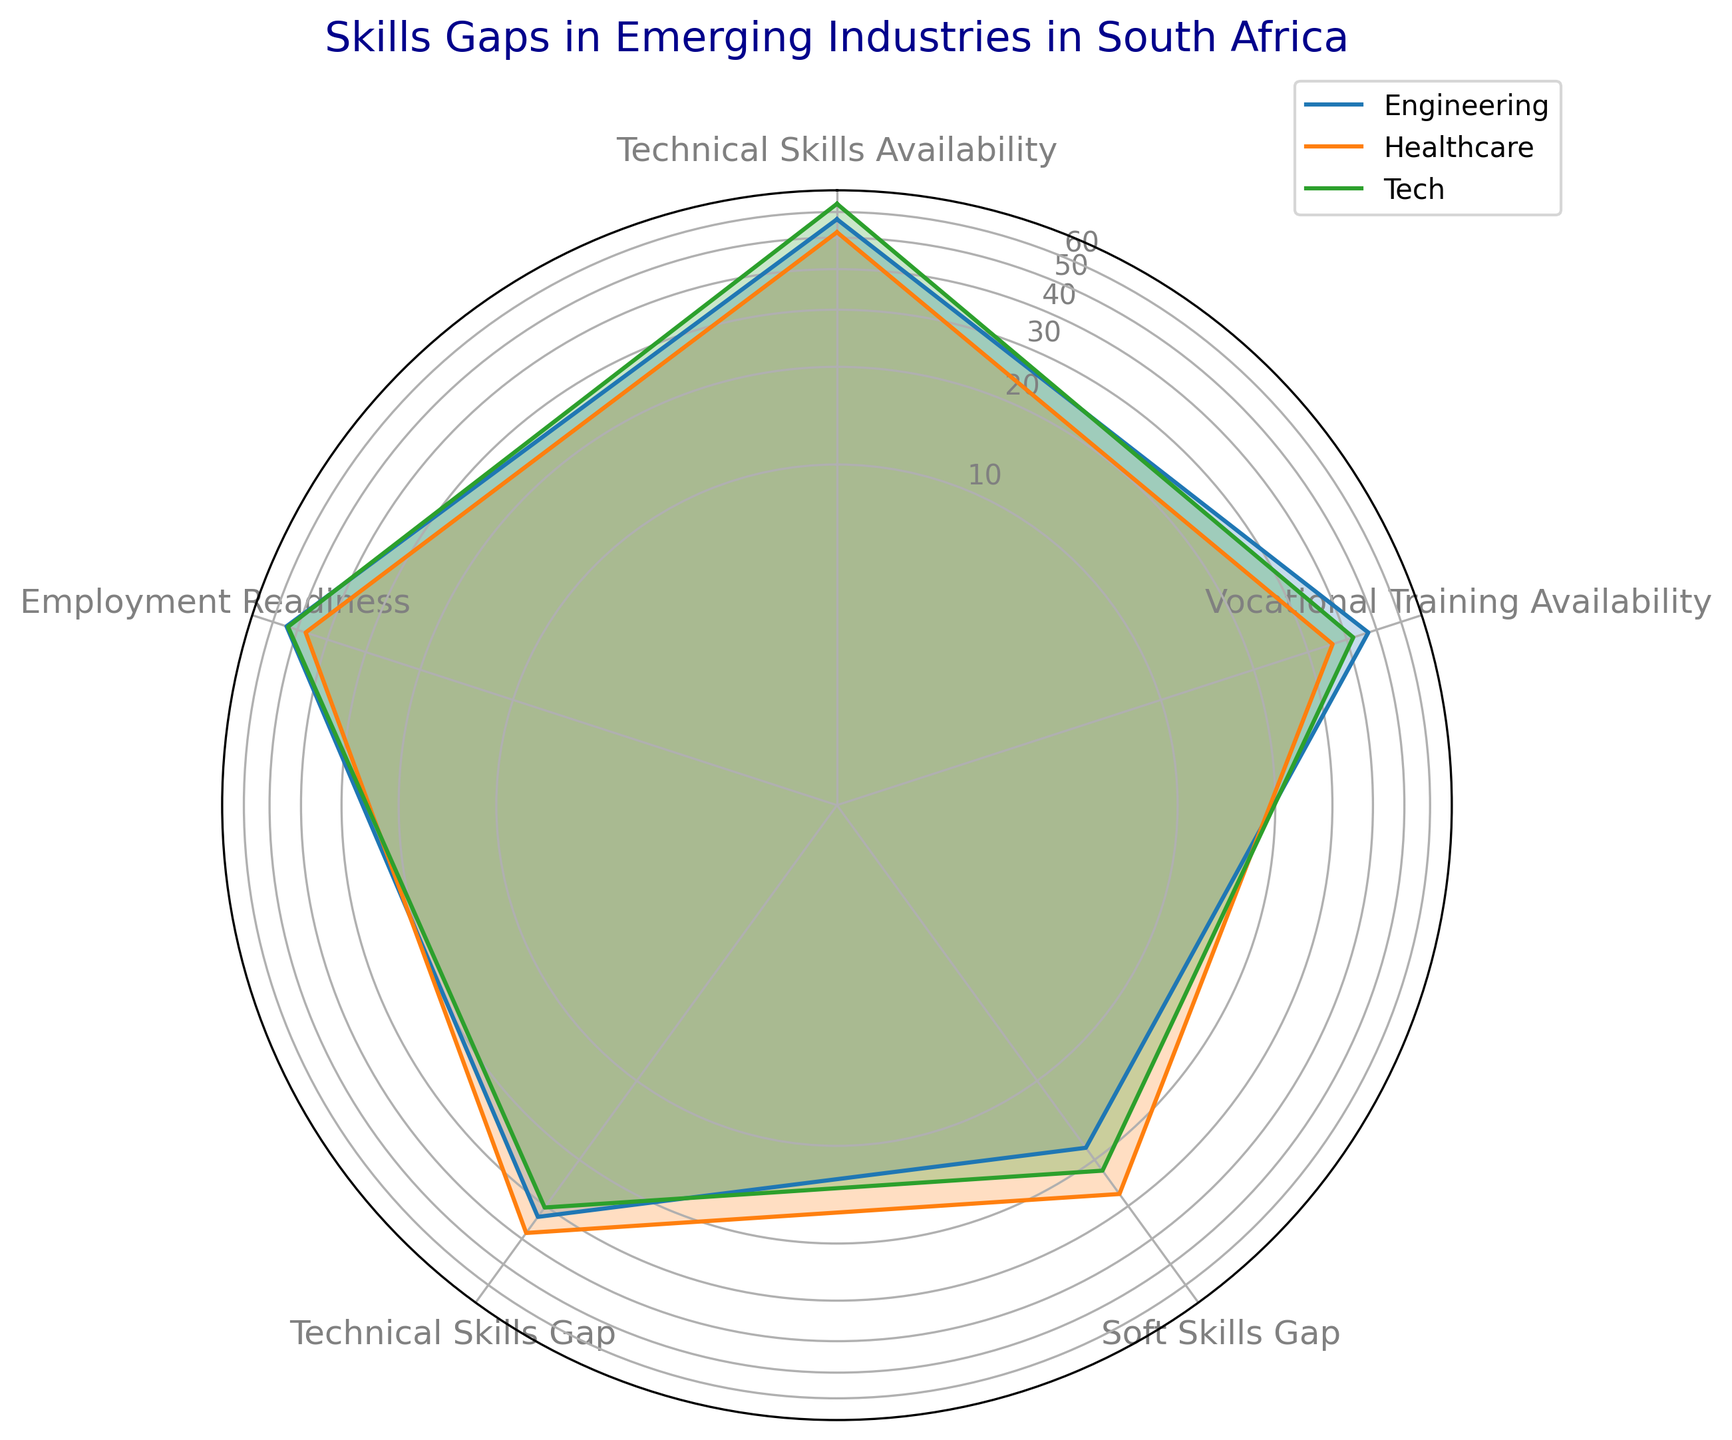What is the difference in average Employment Readiness between Engineering and Healthcare? The average Employment Readiness for Engineering is 54.5, and for Healthcare, it is around 46. The difference is 54.5 - 46 = 8.5.
Answer: 8.5 Which industry has the lowest average Technical Skills Gap, and what is the value? Comparing the Technical Skills Gap for Tech, Healthcare, and Engineering, we find that Engineering has the lowest average Technical Skills Gap. The value is around 32.75.
Answer: Engineering, 32.75 Is the average Vocational Training Availability for Healthcare higher or lower compared to Tech? The average Vocational Training Availability for Healthcare is around 36. More specifically, Healthcare's value is lower than Tech, which has an average of around 42.5.
Answer: Lower Between Tech and Engineering, which industry shows a larger difference between Technical Skills Availability and Vocational Training Availability? For Tech, the difference is 63.5 - 42.5 = 21. For Engineering, the difference is 57.5 - 46.25 = 11.25. Tech shows a larger difference.
Answer: Tech How does average Employment Readiness in Tech compare to other industries? The average Employment Readiness for Tech is around 53.6. For Healthcare it's around 47, and for Engineering it's 54.5. Tech lies between Engineering and Healthcare in Employment Readiness.
Answer: Higher than Healthcare, lower than Engineering average Employment Readiness The average values are Tech: 53.6, Healthcare: 47, Engineering: 54.5. Tech lies between Engineering and Healthcare.
Answer: Higher than Healthcare, lower than Engineering Which industry shows the smallest variance in Technical Skills Availability? By looking at the values, the range for Healthcare is smallest, with values around 50-54, indicating the smallest variance.
Answer: Healthcare 